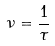Convert formula to latex. <formula><loc_0><loc_0><loc_500><loc_500>\nu = \frac { 1 } { \tau }</formula> 